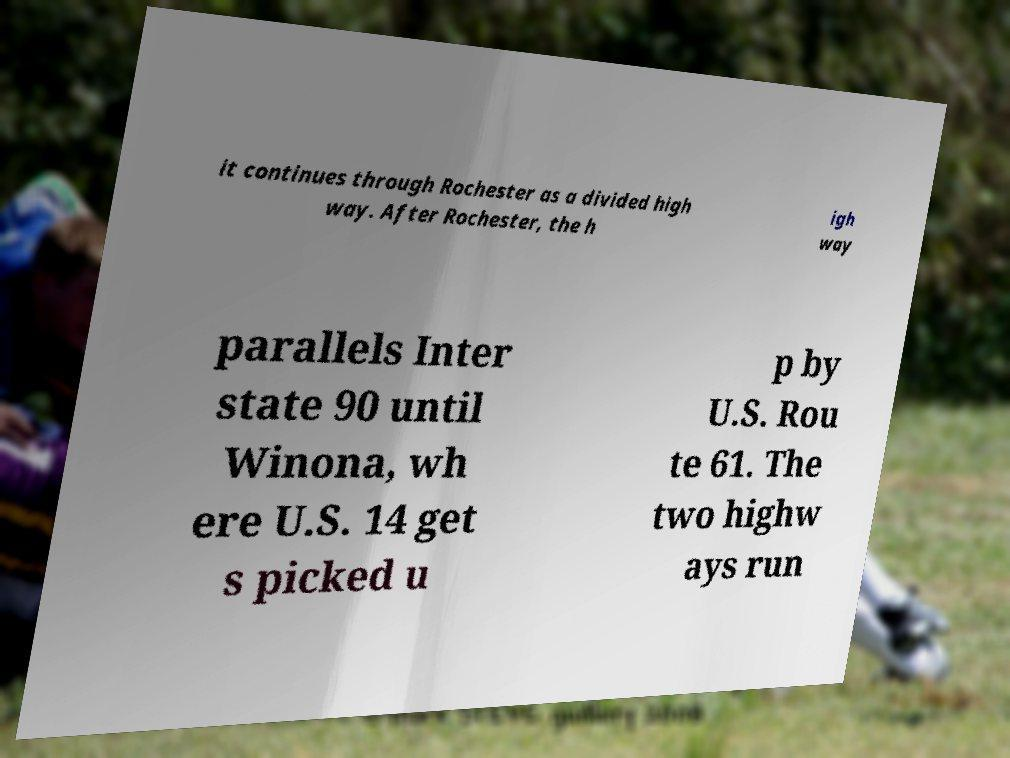Please identify and transcribe the text found in this image. it continues through Rochester as a divided high way. After Rochester, the h igh way parallels Inter state 90 until Winona, wh ere U.S. 14 get s picked u p by U.S. Rou te 61. The two highw ays run 